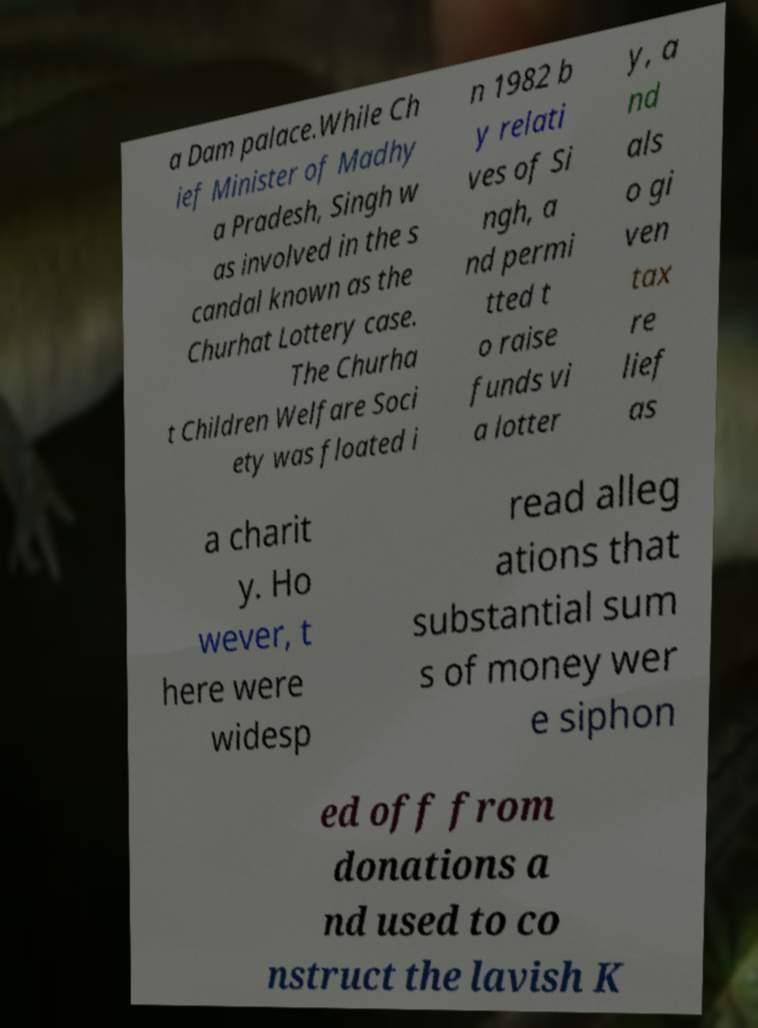I need the written content from this picture converted into text. Can you do that? a Dam palace.While Ch ief Minister of Madhy a Pradesh, Singh w as involved in the s candal known as the Churhat Lottery case. The Churha t Children Welfare Soci ety was floated i n 1982 b y relati ves of Si ngh, a nd permi tted t o raise funds vi a lotter y, a nd als o gi ven tax re lief as a charit y. Ho wever, t here were widesp read alleg ations that substantial sum s of money wer e siphon ed off from donations a nd used to co nstruct the lavish K 